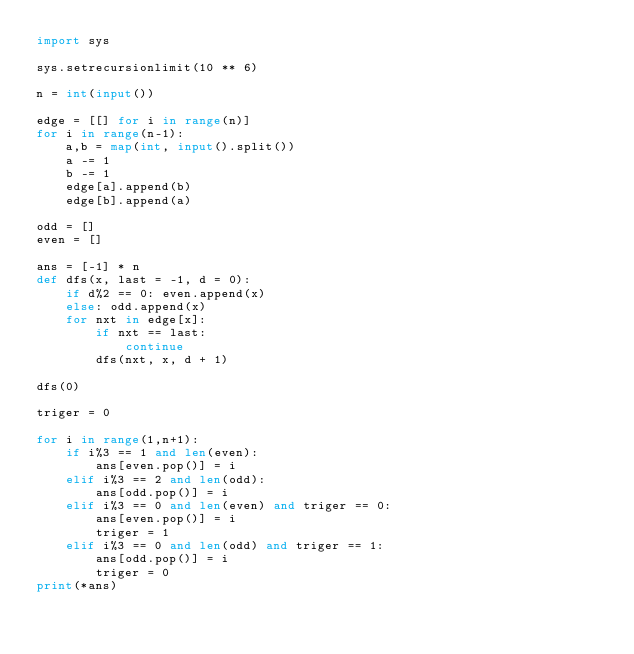Convert code to text. <code><loc_0><loc_0><loc_500><loc_500><_Python_>import sys
 
sys.setrecursionlimit(10 ** 6)

n = int(input())

edge = [[] for i in range(n)]
for i in range(n-1):
    a,b = map(int, input().split())
    a -= 1
    b -= 1
    edge[a].append(b)
    edge[b].append(a)

odd = []
even = []

ans = [-1] * n
def dfs(x, last = -1, d = 0):
    if d%2 == 0: even.append(x)
    else: odd.append(x)
    for nxt in edge[x]:
        if nxt == last:
            continue
        dfs(nxt, x, d + 1)

dfs(0)

triger = 0

for i in range(1,n+1):
    if i%3 == 1 and len(even):
        ans[even.pop()] = i
    elif i%3 == 2 and len(odd):
        ans[odd.pop()] = i
    elif i%3 == 0 and len(even) and triger == 0:
        ans[even.pop()] = i
        triger = 1
    elif i%3 == 0 and len(odd) and triger == 1:
        ans[odd.pop()] = i
        triger = 0
print(*ans)
</code> 